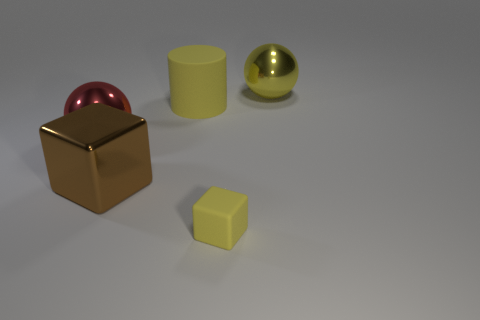Add 1 gray matte blocks. How many objects exist? 6 Subtract all cylinders. How many objects are left? 4 Subtract all small yellow rubber things. Subtract all big yellow metal things. How many objects are left? 3 Add 2 cylinders. How many cylinders are left? 3 Add 1 big yellow things. How many big yellow things exist? 3 Subtract 1 brown blocks. How many objects are left? 4 